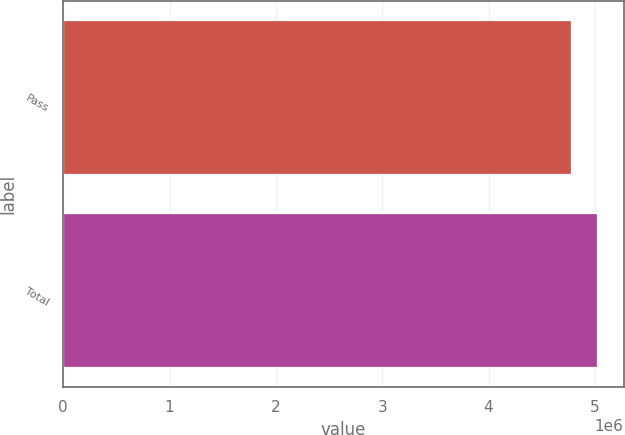Convert chart to OTSL. <chart><loc_0><loc_0><loc_500><loc_500><bar_chart><fcel>Pass<fcel>Total<nl><fcel>4.77774e+06<fcel>5.01883e+06<nl></chart> 